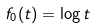<formula> <loc_0><loc_0><loc_500><loc_500>f _ { 0 } ( t ) = \log t</formula> 